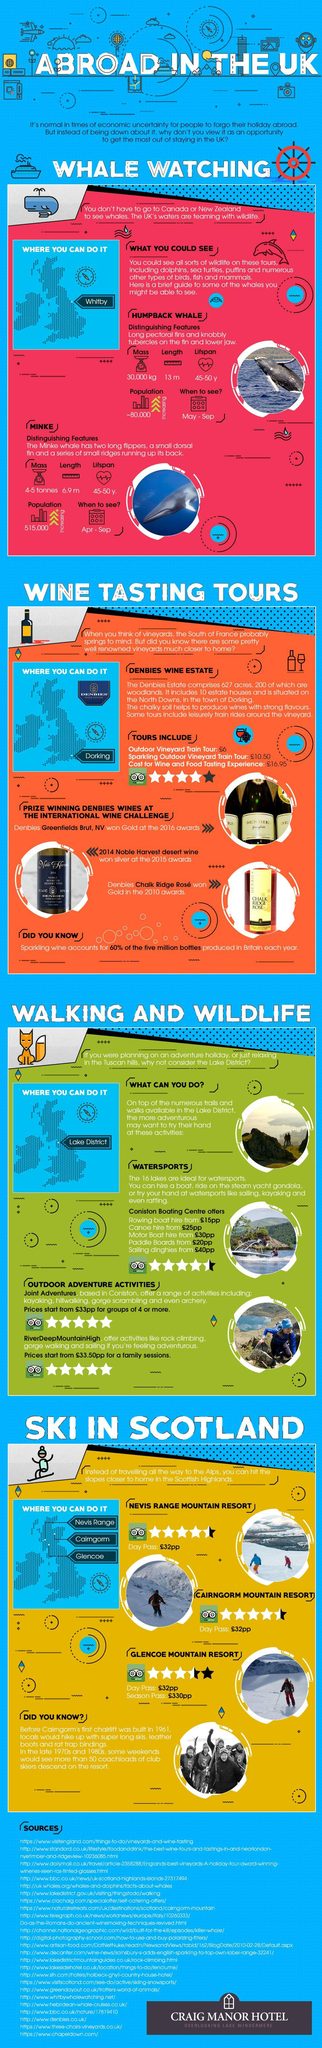Outline some significant characteristics in this image. Scotland offers several regions that are suitable for skiing, including Nevis Range, Cairngorm, and Glencoe. There are several locations where wine tasting tours can be taken, including Dorking and Denbies Wine Estate. The best time to see a Minke whale is from April to September. The best time to see humpback whales is from May to September. Whale watching is possible at Whitby. 